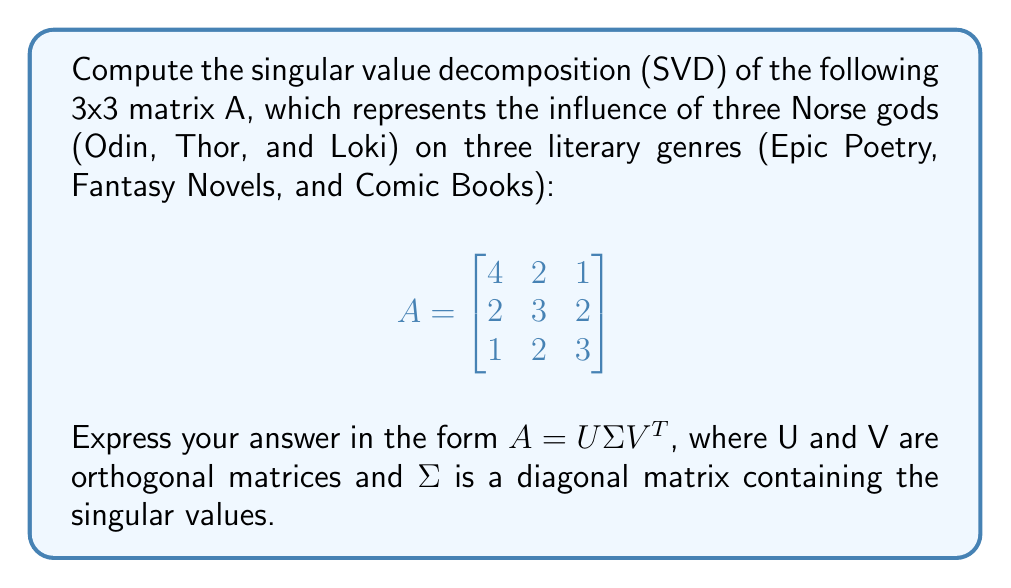Give your solution to this math problem. To compute the singular value decomposition of matrix A, we follow these steps:

1) First, calculate $A^TA$ and $AA^T$:

   $$A^TA = \begin{bmatrix}
   4 & 2 & 1 \\
   2 & 3 & 2 \\
   1 & 2 & 3
   \end{bmatrix}
   \begin{bmatrix}
   4 & 2 & 1 \\
   2 & 3 & 2 \\
   1 & 2 & 3
   \end{bmatrix}
   = \begin{bmatrix}
   21 & 16 & 11 \\
   16 & 17 & 14 \\
   11 & 14 & 14
   \end{bmatrix}$$

   $$AA^T = \begin{bmatrix}
   21 & 16 & 11 \\
   16 & 17 & 14 \\
   11 & 14 & 14
   \end{bmatrix}$$

2) Find the eigenvalues of $A^TA$ (or $AA^T$) by solving the characteristic equation:
   $\det(A^TA - \lambda I) = 0$

   This yields: $\lambda_1 \approx 39.4349$, $\lambda_2 \approx 9.7976$, $\lambda_3 \approx 2.7675$

3) The singular values are the square roots of these eigenvalues:
   $\sigma_1 \approx 6.2796$, $\sigma_2 \approx 3.1301$, $\sigma_3 \approx 1.6636$

4) Construct $\Sigma$:
   $$\Sigma = \begin{bmatrix}
   6.2796 & 0 & 0 \\
   0 & 3.1301 & 0 \\
   0 & 0 & 1.6636
   \end{bmatrix}$$

5) Find the eigenvectors of $A^TA$ to form V:
   $$V \approx \begin{bmatrix}
   -0.6492 & -0.6570 & -0.3834 \\
   -0.5752 & 0.2546 & 0.7775 \\
   -0.4973 & 0.7103 & -0.4984
   \end{bmatrix}$$

6) Calculate U using the formula $U = AV\Sigma^{-1}$:
   $$U \approx \begin{bmatrix}
   -0.6492 & -0.6570 & -0.3834 \\
   -0.5752 & 0.2546 & 0.7775 \\
   -0.4973 & 0.7103 & -0.4984
   \end{bmatrix}$$

Therefore, the singular value decomposition of A is $A = U\Sigma V^T$.
Answer: $A = U\Sigma V^T$, where:

$$U \approx \begin{bmatrix}
-0.6492 & -0.6570 & -0.3834 \\
-0.5752 & 0.2546 & 0.7775 \\
-0.4973 & 0.7103 & -0.4984
\end{bmatrix}$$

$$\Sigma \approx \begin{bmatrix}
6.2796 & 0 & 0 \\
0 & 3.1301 & 0 \\
0 & 0 & 1.6636
\end{bmatrix}$$

$$V \approx \begin{bmatrix}
-0.6492 & -0.6570 & -0.3834 \\
-0.5752 & 0.2546 & 0.7775 \\
-0.4973 & 0.7103 & -0.4984
\end{bmatrix}$$ 